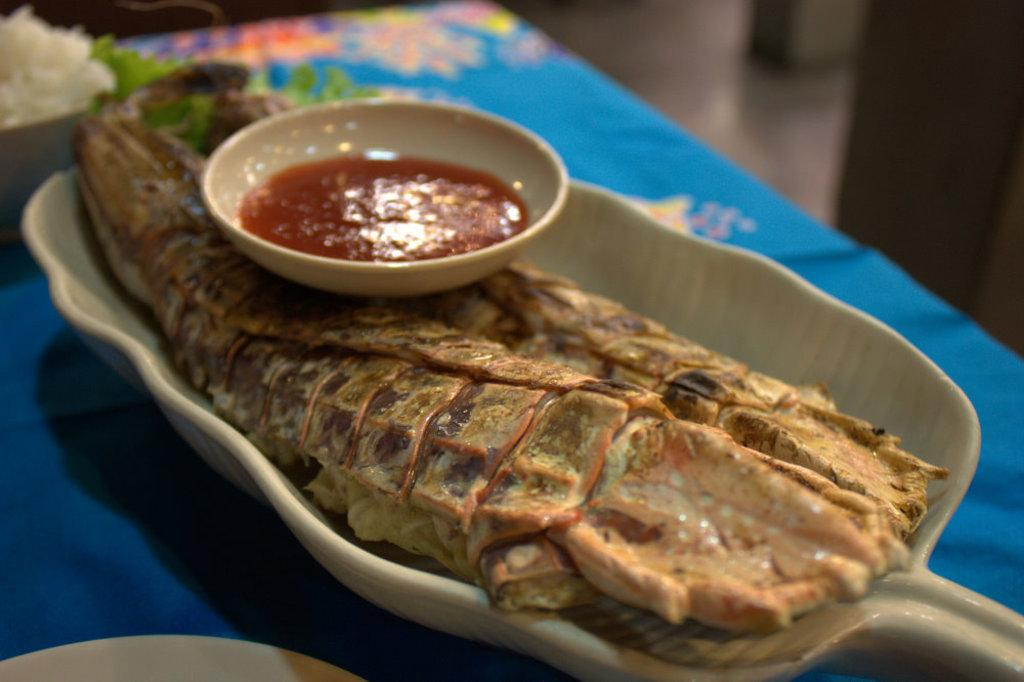What type of food can be seen in the image? There is cooked food in the image. How is the cooked food presented? The cooked food is served on a plate. What accompanies the cooked food on the plate? There is sauce on the plate. Where is the plate with the cooked food located? The plate is placed on a table. What type of cracker is being used for a mass in the image? There is no cracker or mass present in the image; it features cooked food served on a plate with sauce. 